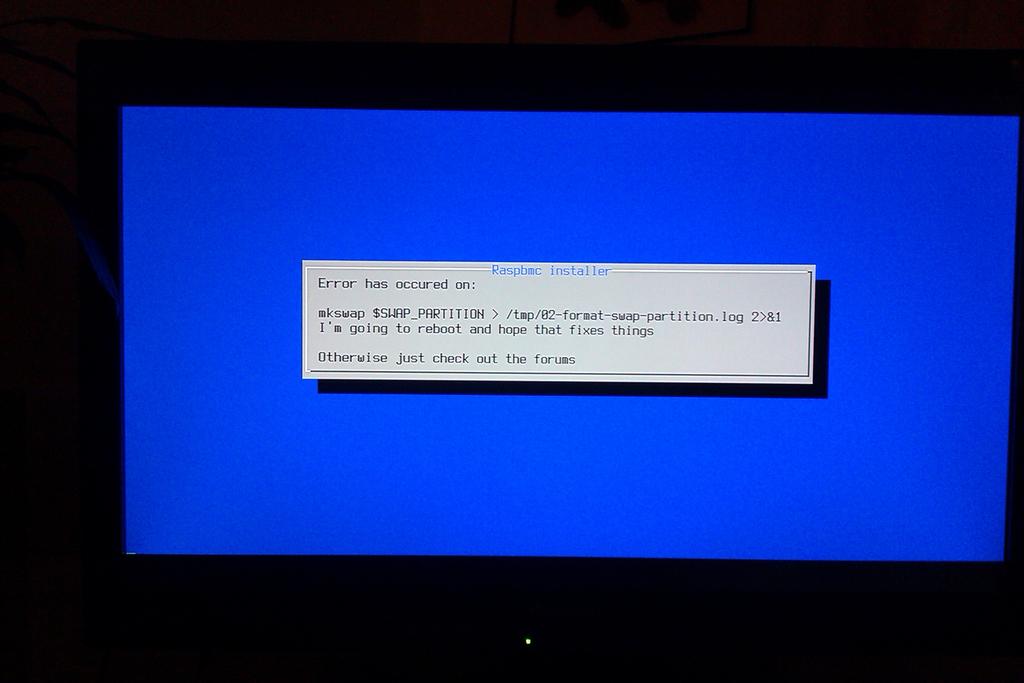What error occurred on the screen?
Give a very brief answer. Unanswerable. What kind of installer is this?
Give a very brief answer. Unanswerable. 